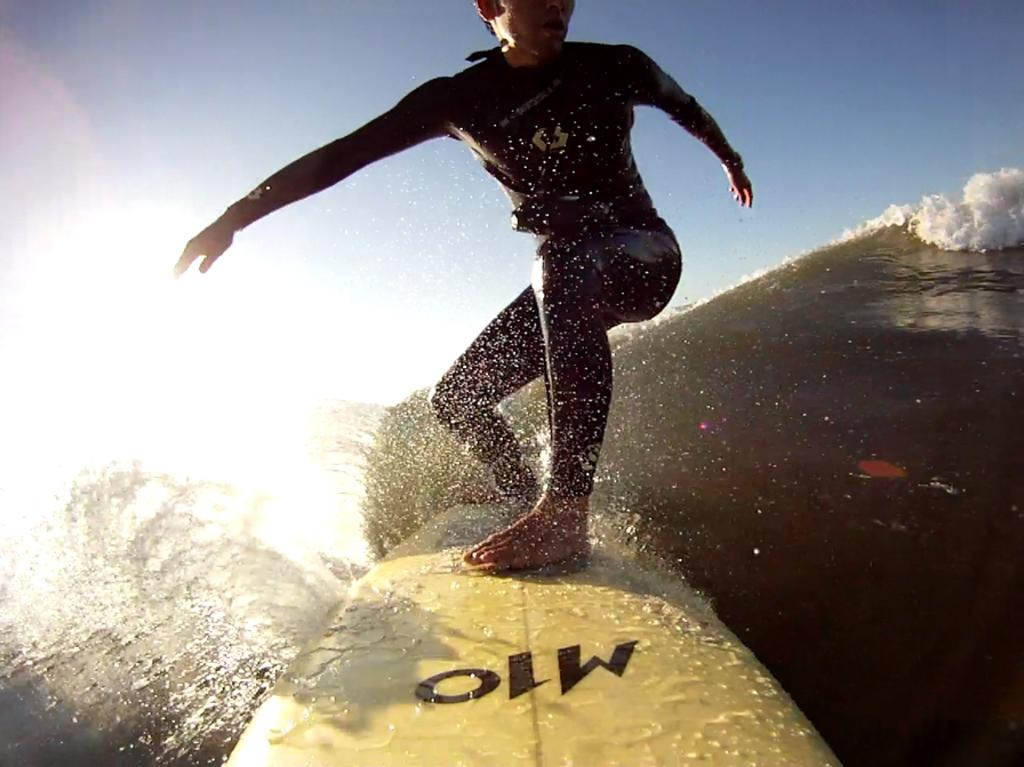What is the main subject of the image? There is a person in the image. What is the person doing in the image? The person is standing on a surfboard. What type of environment is visible in the image? There is water visible in the image. What can be seen in the background of the image? There is sky visible in the background of the image. What type of poison is being used by the person on the surfboard? There is no poison present in the image; the person is simply standing on a surfboard in the water. Can you see any socks on the person in the image? There is no mention of socks in the image, and no socks are visible. 